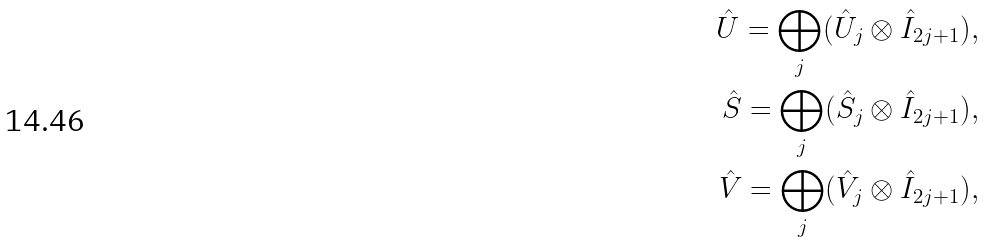<formula> <loc_0><loc_0><loc_500><loc_500>\hat { U } = \bigoplus _ { j } ( \hat { U } _ { j } \otimes \hat { I } _ { 2 j + 1 } ) , \\ \hat { S } = \bigoplus _ { j } ( \hat { S } _ { j } \otimes \hat { I } _ { 2 j + 1 } ) , \\ \hat { V } = \bigoplus _ { j } ( \hat { V } _ { j } \otimes \hat { I } _ { 2 j + 1 } ) ,</formula> 